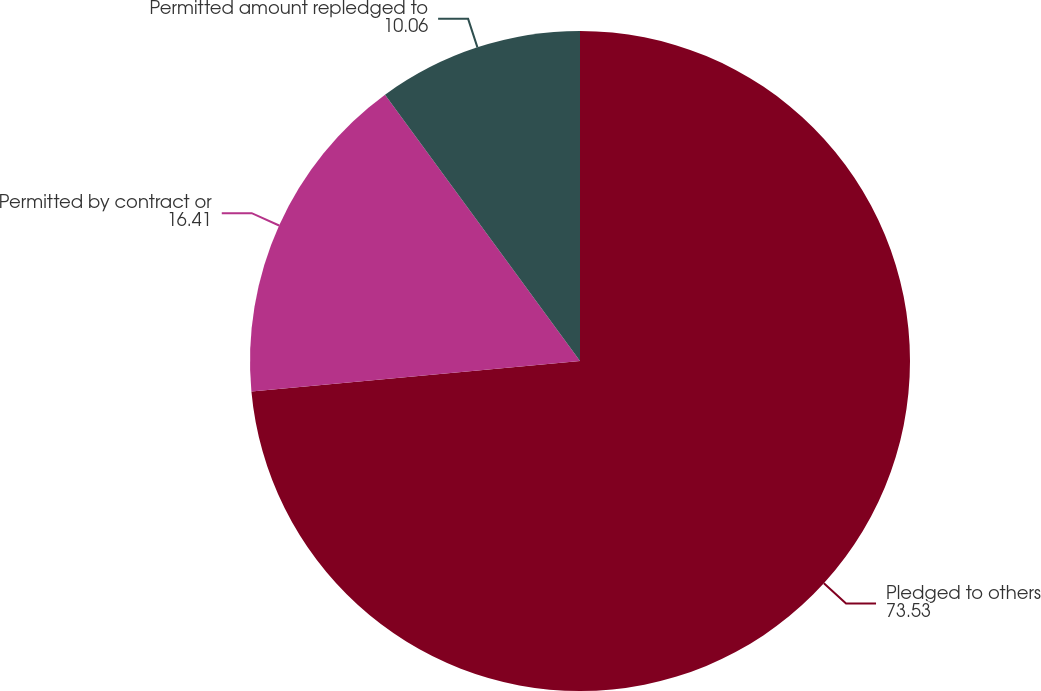<chart> <loc_0><loc_0><loc_500><loc_500><pie_chart><fcel>Pledged to others<fcel>Permitted by contract or<fcel>Permitted amount repledged to<nl><fcel>73.53%<fcel>16.41%<fcel>10.06%<nl></chart> 